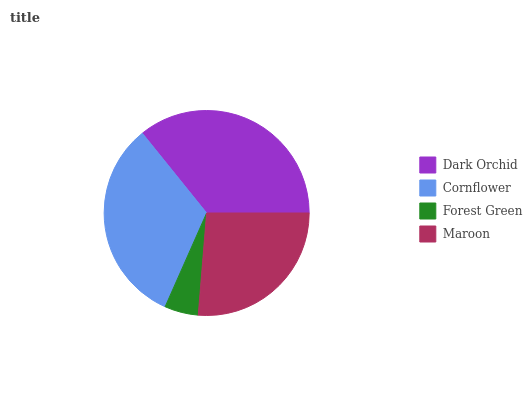Is Forest Green the minimum?
Answer yes or no. Yes. Is Dark Orchid the maximum?
Answer yes or no. Yes. Is Cornflower the minimum?
Answer yes or no. No. Is Cornflower the maximum?
Answer yes or no. No. Is Dark Orchid greater than Cornflower?
Answer yes or no. Yes. Is Cornflower less than Dark Orchid?
Answer yes or no. Yes. Is Cornflower greater than Dark Orchid?
Answer yes or no. No. Is Dark Orchid less than Cornflower?
Answer yes or no. No. Is Cornflower the high median?
Answer yes or no. Yes. Is Maroon the low median?
Answer yes or no. Yes. Is Forest Green the high median?
Answer yes or no. No. Is Cornflower the low median?
Answer yes or no. No. 